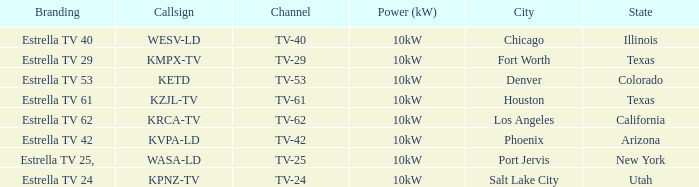What's the power output for channel tv-29? 10kW. 